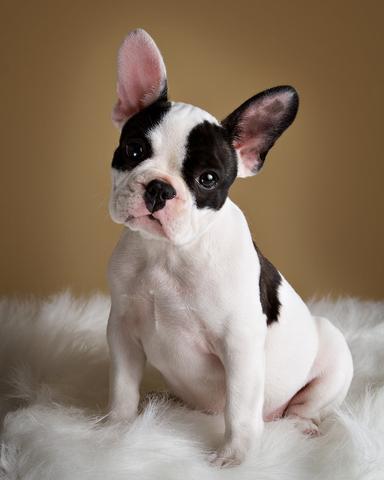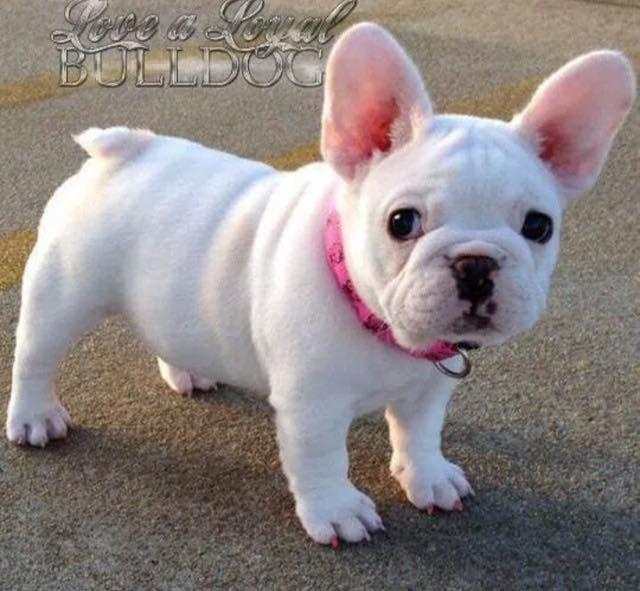The first image is the image on the left, the second image is the image on the right. Analyze the images presented: Is the assertion "The right image shows two dogs, while the left image shows just one" valid? Answer yes or no. No. The first image is the image on the left, the second image is the image on the right. Analyze the images presented: Is the assertion "There are two dogs in the right image." valid? Answer yes or no. No. 